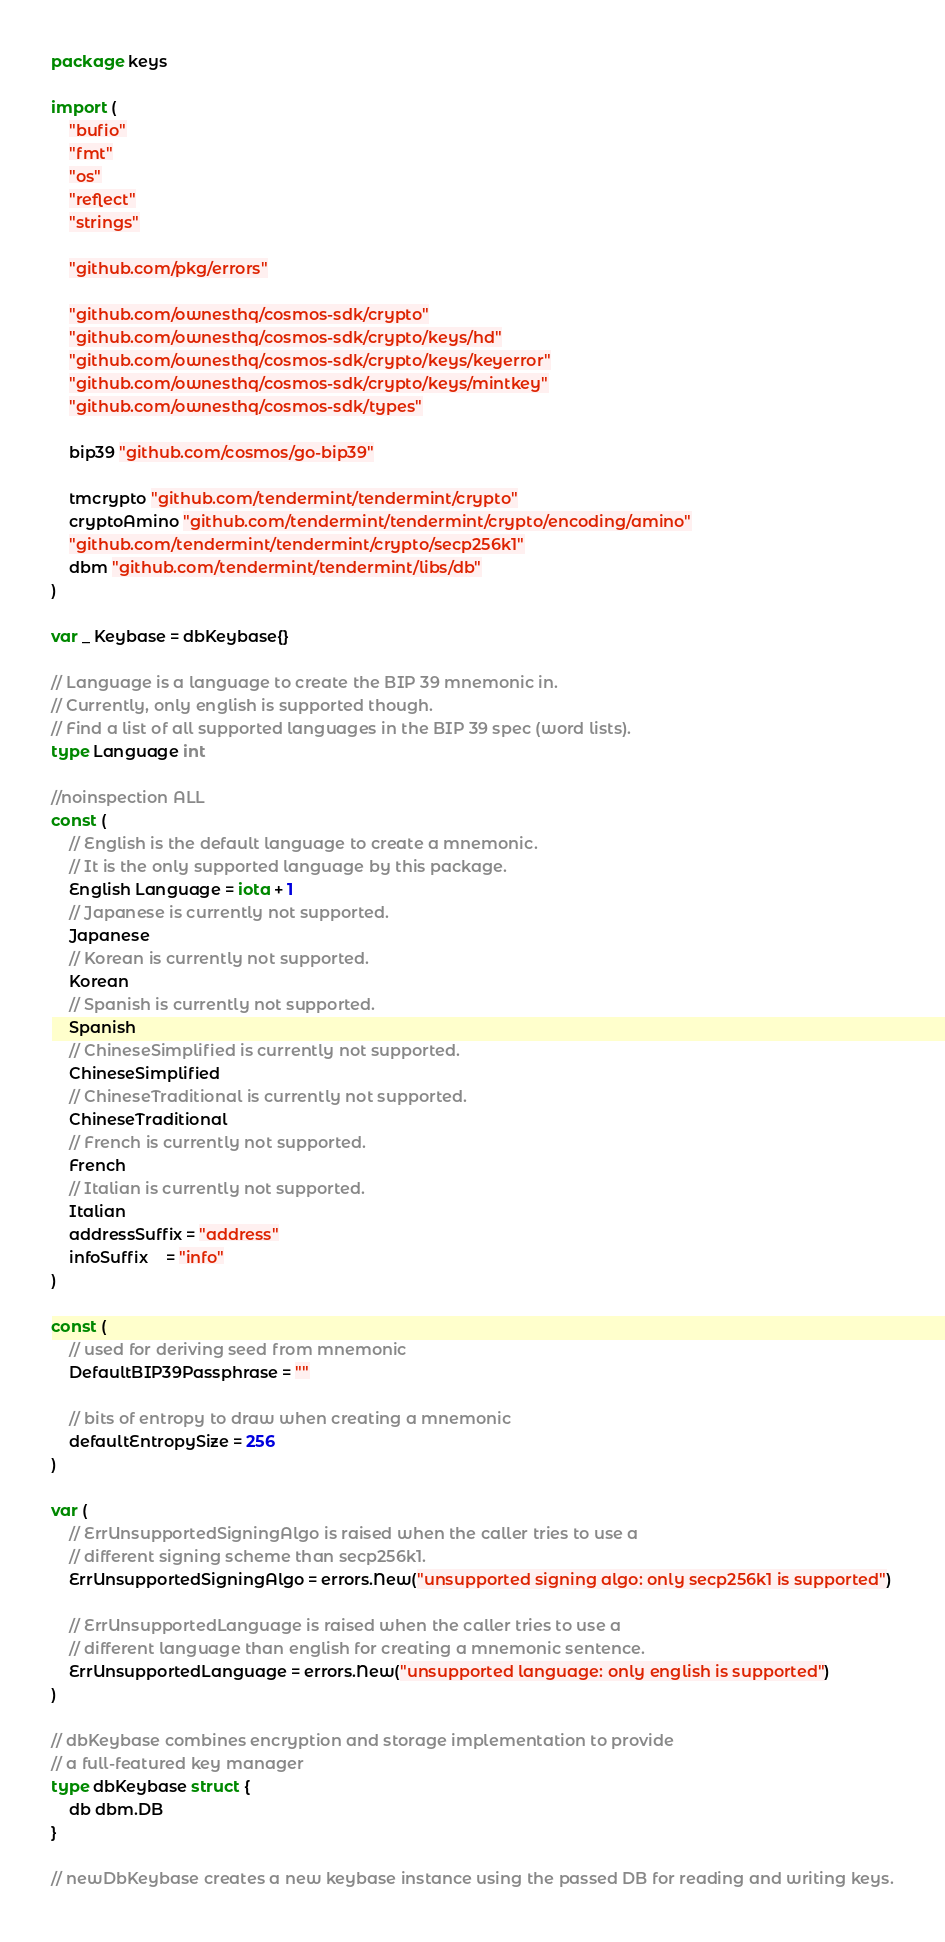<code> <loc_0><loc_0><loc_500><loc_500><_Go_>package keys

import (
	"bufio"
	"fmt"
	"os"
	"reflect"
	"strings"

	"github.com/pkg/errors"

	"github.com/ownesthq/cosmos-sdk/crypto"
	"github.com/ownesthq/cosmos-sdk/crypto/keys/hd"
	"github.com/ownesthq/cosmos-sdk/crypto/keys/keyerror"
	"github.com/ownesthq/cosmos-sdk/crypto/keys/mintkey"
	"github.com/ownesthq/cosmos-sdk/types"

	bip39 "github.com/cosmos/go-bip39"

	tmcrypto "github.com/tendermint/tendermint/crypto"
	cryptoAmino "github.com/tendermint/tendermint/crypto/encoding/amino"
	"github.com/tendermint/tendermint/crypto/secp256k1"
	dbm "github.com/tendermint/tendermint/libs/db"
)

var _ Keybase = dbKeybase{}

// Language is a language to create the BIP 39 mnemonic in.
// Currently, only english is supported though.
// Find a list of all supported languages in the BIP 39 spec (word lists).
type Language int

//noinspection ALL
const (
	// English is the default language to create a mnemonic.
	// It is the only supported language by this package.
	English Language = iota + 1
	// Japanese is currently not supported.
	Japanese
	// Korean is currently not supported.
	Korean
	// Spanish is currently not supported.
	Spanish
	// ChineseSimplified is currently not supported.
	ChineseSimplified
	// ChineseTraditional is currently not supported.
	ChineseTraditional
	// French is currently not supported.
	French
	// Italian is currently not supported.
	Italian
	addressSuffix = "address"
	infoSuffix    = "info"
)

const (
	// used for deriving seed from mnemonic
	DefaultBIP39Passphrase = ""

	// bits of entropy to draw when creating a mnemonic
	defaultEntropySize = 256
)

var (
	// ErrUnsupportedSigningAlgo is raised when the caller tries to use a
	// different signing scheme than secp256k1.
	ErrUnsupportedSigningAlgo = errors.New("unsupported signing algo: only secp256k1 is supported")

	// ErrUnsupportedLanguage is raised when the caller tries to use a
	// different language than english for creating a mnemonic sentence.
	ErrUnsupportedLanguage = errors.New("unsupported language: only english is supported")
)

// dbKeybase combines encryption and storage implementation to provide
// a full-featured key manager
type dbKeybase struct {
	db dbm.DB
}

// newDbKeybase creates a new keybase instance using the passed DB for reading and writing keys.</code> 